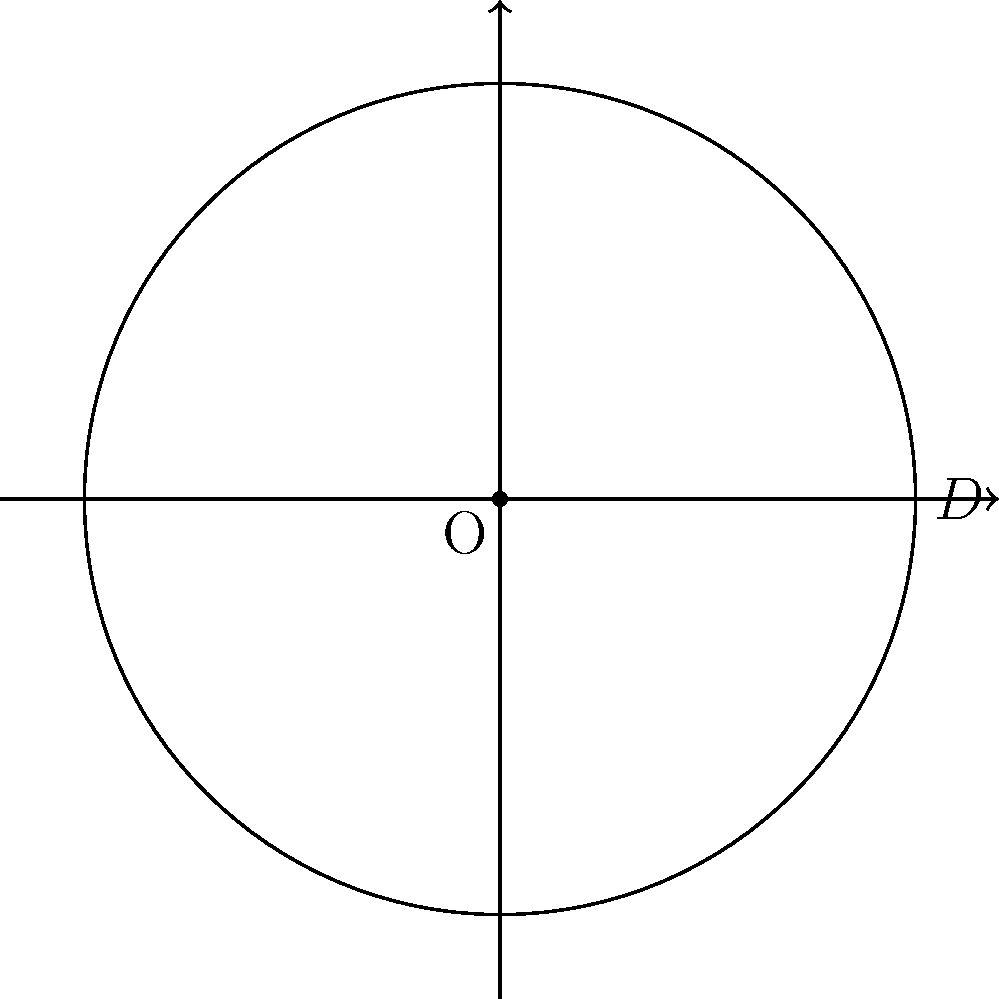As a retro DJ, you're preparing for a groovy movie night. You've got a vintage vinyl record with a diameter of 12 inches. What's the circumference of this funky disc, rounded to the nearest tenth of an inch? Assume $\pi \approx 3.14159$. Let's break it down, step by step:

1) The formula for the circumference of a circle is:
   $$C = \pi D$$
   where $C$ is the circumference, $\pi$ is pi, and $D$ is the diameter.

2) We're given that the diameter $D$ is 12 inches.

3) Substituting the values into our formula:
   $$C = \pi \times 12$$

4) Using the given approximation for $\pi$:
   $$C = 3.14159 \times 12$$

5) Calculating this:
   $$C = 37.69908 \text{ inches}$$

6) Rounding to the nearest tenth:
   $$C \approx 37.7 \text{ inches}$$

So, your vintage vinyl has a circumference of approximately 37.7 inches. That's one groovy circle of sound!
Answer: 37.7 inches 